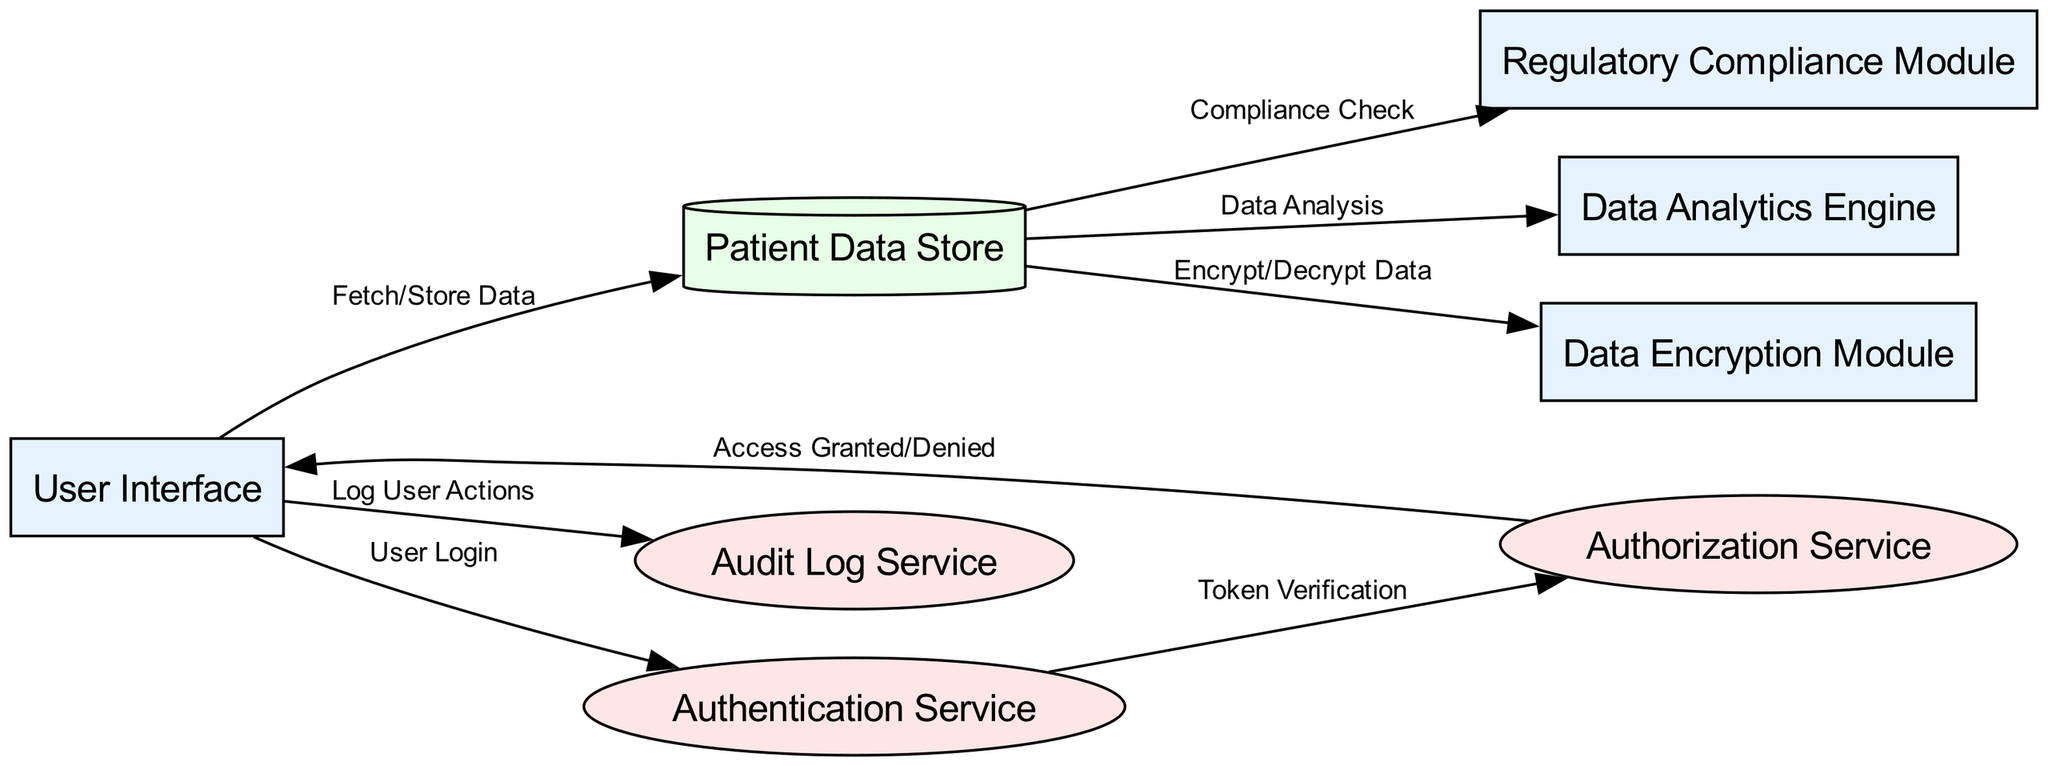What is the total number of nodes in the diagram? The diagram contains eight distinct nodes, which are labeled as: User Interface, Authentication Service, Authorization Service, Patient Data Store, Data Encryption Module, Audit Log Service, Regulatory Compliance Module, and Data Analytics Engine.
Answer: 8 Which node is responsible for user login? The User Interface is the node directly responsible for user login, as indicated by the connection labeled 'User Login' from the User Interface to the Authentication Service.
Answer: User Interface What type of component is the Patient Data Store? The Patient Data Store is classified as a database, which is visually represented in the diagram by its cylindrical shape.
Answer: database Describe the flow of actions after a user logs in. When a user logs in through the User Interface, the flow proceeds to the Authentication Service for token verification. If successful, it continues to the Authorization Service for access granting or denial, followed by actions involving fetching or storing data in the Patient Data Store.
Answer: Authentication Service, Authorization Service, Patient Data Store Which component handles compliance checks for data? The Regulatory Compliance Module is designated for handling compliance checks related to the patient data in the architecture, as shown by its direct connection to the Patient Data Store labeled 'Compliance Check'.
Answer: Regulatory Compliance Module How many services are represented in the diagram? There are three services depicted in the diagram: Authentication Service, Authorization Service, and Audit Log Service. Each service types are indicated visibly by the elliptical shapes.
Answer: 3 What action is performed by the Data Encryption Module? The Data Encryption Module manages the encryption and decryption of data as indicated by the edge labeled 'Encrypt/Decrypt Data' connecting it to the Patient Data Store.
Answer: Encrypt/Decrypt Data What is the function of the Audit Log Service? The Audit Log Service logs user actions to maintain records of user interactions with the system, following the edge labeled 'Log User Actions' from User Interface to Audit Log Service.
Answer: Log User Actions 